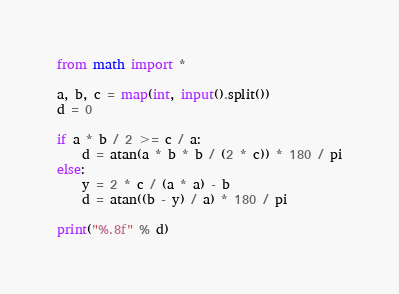<code> <loc_0><loc_0><loc_500><loc_500><_Python_>from math import *

a, b, c = map(int, input().split())
d = 0

if a * b / 2 >= c / a:
    d = atan(a * b * b / (2 * c)) * 180 / pi
else:
    y = 2 * c / (a * a) - b
    d = atan((b - y) / a) * 180 / pi

print("%.8f" % d)</code> 